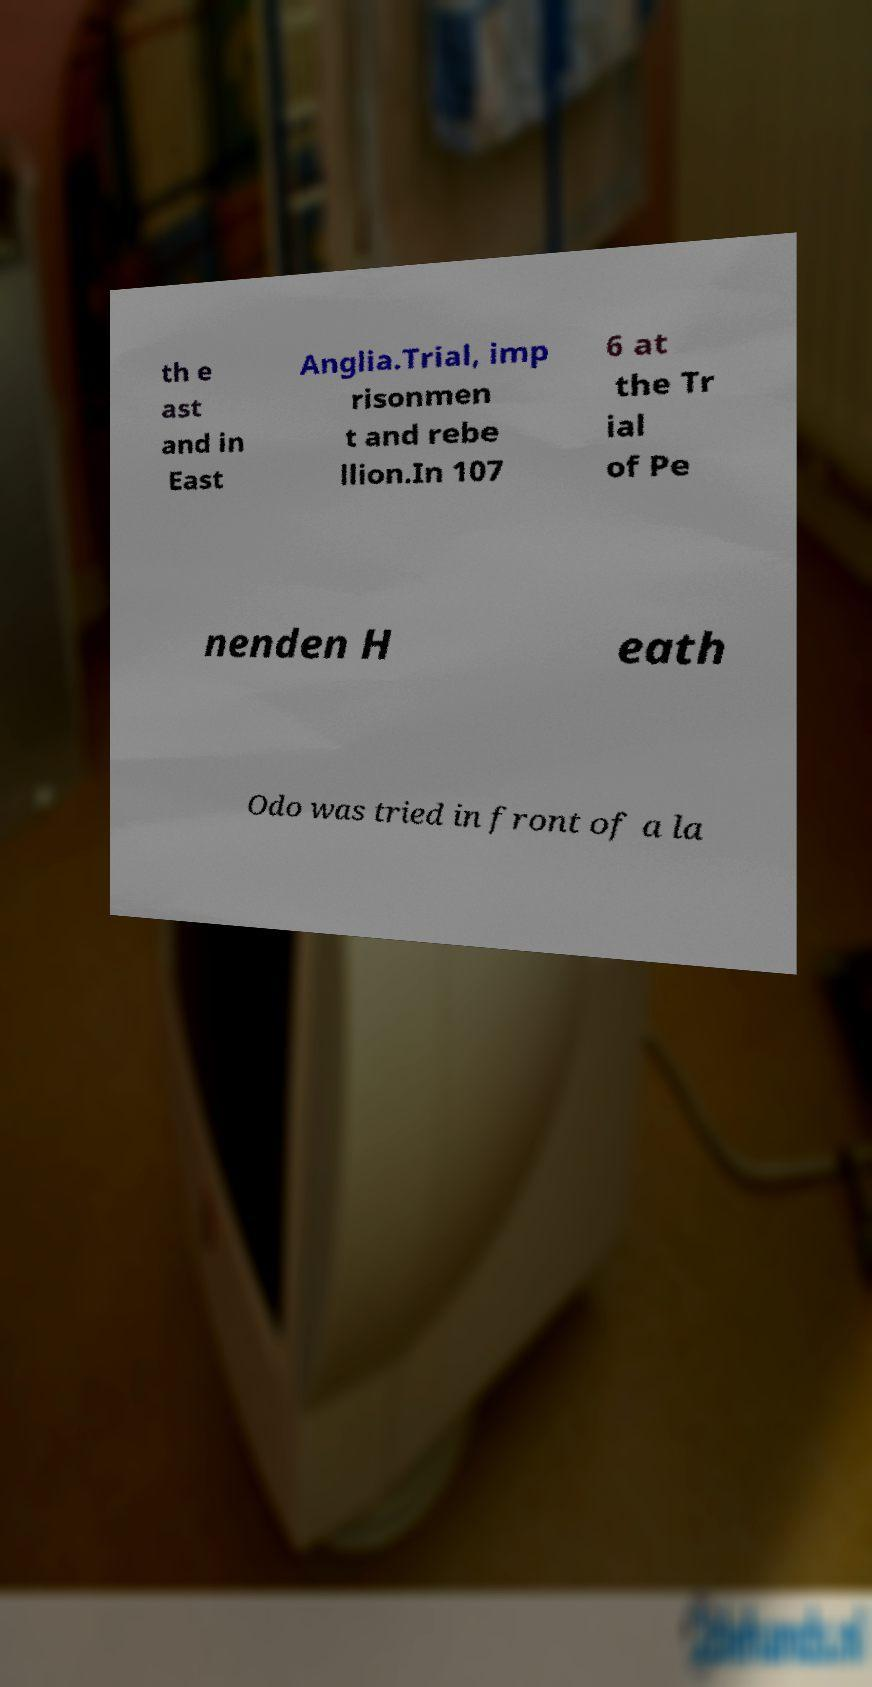I need the written content from this picture converted into text. Can you do that? th e ast and in East Anglia.Trial, imp risonmen t and rebe llion.In 107 6 at the Tr ial of Pe nenden H eath Odo was tried in front of a la 